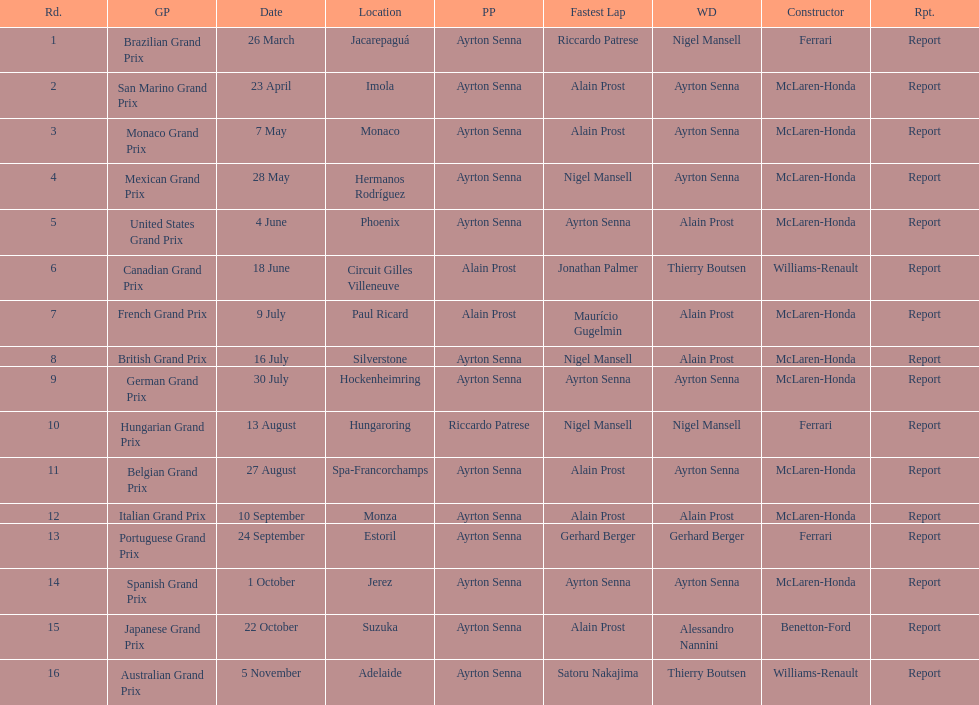Prost claimed the drivers title, who was his colleague? Ayrton Senna. 